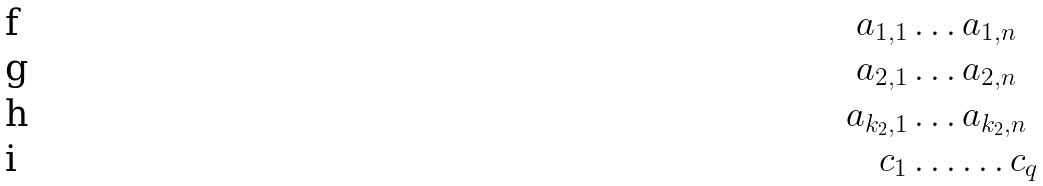<formula> <loc_0><loc_0><loc_500><loc_500>a _ { 1 , 1 } & \dots a _ { 1 , n } \\ a _ { 2 , 1 } & \dots a _ { 2 , n } \\ a _ { k _ { 2 } , 1 } & \dots a _ { k _ { 2 } , n } \\ c _ { 1 } & \dots \dots c _ { q }</formula> 